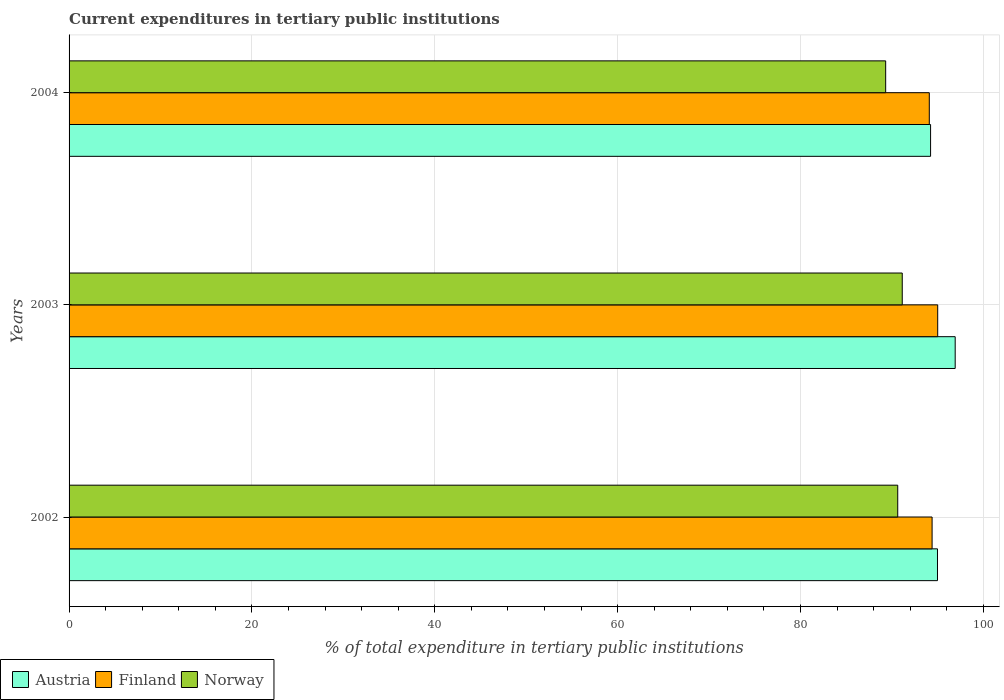How many groups of bars are there?
Provide a short and direct response. 3. Are the number of bars per tick equal to the number of legend labels?
Your answer should be compact. Yes. How many bars are there on the 1st tick from the bottom?
Make the answer very short. 3. What is the label of the 2nd group of bars from the top?
Your response must be concise. 2003. What is the current expenditures in tertiary public institutions in Finland in 2002?
Offer a terse response. 94.4. Across all years, what is the maximum current expenditures in tertiary public institutions in Norway?
Offer a terse response. 91.14. Across all years, what is the minimum current expenditures in tertiary public institutions in Finland?
Provide a succinct answer. 94.09. In which year was the current expenditures in tertiary public institutions in Austria maximum?
Ensure brevity in your answer.  2003. What is the total current expenditures in tertiary public institutions in Austria in the graph?
Provide a short and direct response. 286.15. What is the difference between the current expenditures in tertiary public institutions in Norway in 2003 and that in 2004?
Make the answer very short. 1.81. What is the difference between the current expenditures in tertiary public institutions in Finland in 2003 and the current expenditures in tertiary public institutions in Austria in 2002?
Make the answer very short. 0.02. What is the average current expenditures in tertiary public institutions in Norway per year?
Make the answer very short. 90.37. In the year 2004, what is the difference between the current expenditures in tertiary public institutions in Finland and current expenditures in tertiary public institutions in Norway?
Your answer should be very brief. 4.77. What is the ratio of the current expenditures in tertiary public institutions in Finland in 2002 to that in 2003?
Your answer should be very brief. 0.99. Is the current expenditures in tertiary public institutions in Austria in 2002 less than that in 2003?
Provide a succinct answer. Yes. What is the difference between the highest and the second highest current expenditures in tertiary public institutions in Finland?
Your answer should be compact. 0.61. What is the difference between the highest and the lowest current expenditures in tertiary public institutions in Finland?
Keep it short and to the point. 0.92. Is the sum of the current expenditures in tertiary public institutions in Austria in 2003 and 2004 greater than the maximum current expenditures in tertiary public institutions in Finland across all years?
Offer a terse response. Yes. Is it the case that in every year, the sum of the current expenditures in tertiary public institutions in Norway and current expenditures in tertiary public institutions in Austria is greater than the current expenditures in tertiary public institutions in Finland?
Your response must be concise. Yes. How many bars are there?
Ensure brevity in your answer.  9. Are all the bars in the graph horizontal?
Your answer should be compact. Yes. Does the graph contain any zero values?
Make the answer very short. No. How many legend labels are there?
Give a very brief answer. 3. What is the title of the graph?
Ensure brevity in your answer.  Current expenditures in tertiary public institutions. Does "East Asia (all income levels)" appear as one of the legend labels in the graph?
Offer a very short reply. No. What is the label or title of the X-axis?
Give a very brief answer. % of total expenditure in tertiary public institutions. What is the label or title of the Y-axis?
Your response must be concise. Years. What is the % of total expenditure in tertiary public institutions in Austria in 2002?
Keep it short and to the point. 94.99. What is the % of total expenditure in tertiary public institutions in Finland in 2002?
Offer a terse response. 94.4. What is the % of total expenditure in tertiary public institutions in Norway in 2002?
Provide a succinct answer. 90.64. What is the % of total expenditure in tertiary public institutions of Austria in 2003?
Your response must be concise. 96.93. What is the % of total expenditure in tertiary public institutions in Finland in 2003?
Provide a short and direct response. 95.01. What is the % of total expenditure in tertiary public institutions in Norway in 2003?
Provide a succinct answer. 91.14. What is the % of total expenditure in tertiary public institutions of Austria in 2004?
Your answer should be compact. 94.23. What is the % of total expenditure in tertiary public institutions in Finland in 2004?
Provide a succinct answer. 94.09. What is the % of total expenditure in tertiary public institutions of Norway in 2004?
Provide a succinct answer. 89.32. Across all years, what is the maximum % of total expenditure in tertiary public institutions of Austria?
Keep it short and to the point. 96.93. Across all years, what is the maximum % of total expenditure in tertiary public institutions in Finland?
Ensure brevity in your answer.  95.01. Across all years, what is the maximum % of total expenditure in tertiary public institutions of Norway?
Ensure brevity in your answer.  91.14. Across all years, what is the minimum % of total expenditure in tertiary public institutions of Austria?
Ensure brevity in your answer.  94.23. Across all years, what is the minimum % of total expenditure in tertiary public institutions in Finland?
Your response must be concise. 94.09. Across all years, what is the minimum % of total expenditure in tertiary public institutions of Norway?
Ensure brevity in your answer.  89.32. What is the total % of total expenditure in tertiary public institutions in Austria in the graph?
Your answer should be very brief. 286.15. What is the total % of total expenditure in tertiary public institutions of Finland in the graph?
Your response must be concise. 283.51. What is the total % of total expenditure in tertiary public institutions in Norway in the graph?
Provide a succinct answer. 271.1. What is the difference between the % of total expenditure in tertiary public institutions of Austria in 2002 and that in 2003?
Offer a terse response. -1.94. What is the difference between the % of total expenditure in tertiary public institutions of Finland in 2002 and that in 2003?
Your response must be concise. -0.61. What is the difference between the % of total expenditure in tertiary public institutions of Norway in 2002 and that in 2003?
Provide a succinct answer. -0.49. What is the difference between the % of total expenditure in tertiary public institutions of Austria in 2002 and that in 2004?
Your response must be concise. 0.76. What is the difference between the % of total expenditure in tertiary public institutions in Finland in 2002 and that in 2004?
Offer a terse response. 0.31. What is the difference between the % of total expenditure in tertiary public institutions of Norway in 2002 and that in 2004?
Your answer should be compact. 1.32. What is the difference between the % of total expenditure in tertiary public institutions in Austria in 2003 and that in 2004?
Your response must be concise. 2.69. What is the difference between the % of total expenditure in tertiary public institutions in Finland in 2003 and that in 2004?
Your answer should be compact. 0.92. What is the difference between the % of total expenditure in tertiary public institutions of Norway in 2003 and that in 2004?
Ensure brevity in your answer.  1.81. What is the difference between the % of total expenditure in tertiary public institutions of Austria in 2002 and the % of total expenditure in tertiary public institutions of Finland in 2003?
Provide a succinct answer. -0.02. What is the difference between the % of total expenditure in tertiary public institutions of Austria in 2002 and the % of total expenditure in tertiary public institutions of Norway in 2003?
Provide a short and direct response. 3.85. What is the difference between the % of total expenditure in tertiary public institutions of Finland in 2002 and the % of total expenditure in tertiary public institutions of Norway in 2003?
Your response must be concise. 3.26. What is the difference between the % of total expenditure in tertiary public institutions of Austria in 2002 and the % of total expenditure in tertiary public institutions of Finland in 2004?
Give a very brief answer. 0.9. What is the difference between the % of total expenditure in tertiary public institutions in Austria in 2002 and the % of total expenditure in tertiary public institutions in Norway in 2004?
Provide a succinct answer. 5.67. What is the difference between the % of total expenditure in tertiary public institutions of Finland in 2002 and the % of total expenditure in tertiary public institutions of Norway in 2004?
Your response must be concise. 5.08. What is the difference between the % of total expenditure in tertiary public institutions in Austria in 2003 and the % of total expenditure in tertiary public institutions in Finland in 2004?
Provide a succinct answer. 2.83. What is the difference between the % of total expenditure in tertiary public institutions in Austria in 2003 and the % of total expenditure in tertiary public institutions in Norway in 2004?
Your answer should be compact. 7.6. What is the difference between the % of total expenditure in tertiary public institutions in Finland in 2003 and the % of total expenditure in tertiary public institutions in Norway in 2004?
Give a very brief answer. 5.69. What is the average % of total expenditure in tertiary public institutions in Austria per year?
Your response must be concise. 95.38. What is the average % of total expenditure in tertiary public institutions of Finland per year?
Provide a succinct answer. 94.5. What is the average % of total expenditure in tertiary public institutions of Norway per year?
Your response must be concise. 90.37. In the year 2002, what is the difference between the % of total expenditure in tertiary public institutions of Austria and % of total expenditure in tertiary public institutions of Finland?
Provide a short and direct response. 0.59. In the year 2002, what is the difference between the % of total expenditure in tertiary public institutions of Austria and % of total expenditure in tertiary public institutions of Norway?
Ensure brevity in your answer.  4.35. In the year 2002, what is the difference between the % of total expenditure in tertiary public institutions in Finland and % of total expenditure in tertiary public institutions in Norway?
Your response must be concise. 3.76. In the year 2003, what is the difference between the % of total expenditure in tertiary public institutions in Austria and % of total expenditure in tertiary public institutions in Finland?
Provide a succinct answer. 1.91. In the year 2003, what is the difference between the % of total expenditure in tertiary public institutions of Austria and % of total expenditure in tertiary public institutions of Norway?
Provide a succinct answer. 5.79. In the year 2003, what is the difference between the % of total expenditure in tertiary public institutions in Finland and % of total expenditure in tertiary public institutions in Norway?
Your answer should be compact. 3.88. In the year 2004, what is the difference between the % of total expenditure in tertiary public institutions in Austria and % of total expenditure in tertiary public institutions in Finland?
Give a very brief answer. 0.14. In the year 2004, what is the difference between the % of total expenditure in tertiary public institutions of Austria and % of total expenditure in tertiary public institutions of Norway?
Provide a succinct answer. 4.91. In the year 2004, what is the difference between the % of total expenditure in tertiary public institutions of Finland and % of total expenditure in tertiary public institutions of Norway?
Ensure brevity in your answer.  4.77. What is the ratio of the % of total expenditure in tertiary public institutions of Finland in 2002 to that in 2003?
Keep it short and to the point. 0.99. What is the ratio of the % of total expenditure in tertiary public institutions in Austria in 2002 to that in 2004?
Offer a very short reply. 1.01. What is the ratio of the % of total expenditure in tertiary public institutions of Norway in 2002 to that in 2004?
Provide a short and direct response. 1.01. What is the ratio of the % of total expenditure in tertiary public institutions in Austria in 2003 to that in 2004?
Offer a terse response. 1.03. What is the ratio of the % of total expenditure in tertiary public institutions in Finland in 2003 to that in 2004?
Your response must be concise. 1.01. What is the ratio of the % of total expenditure in tertiary public institutions in Norway in 2003 to that in 2004?
Keep it short and to the point. 1.02. What is the difference between the highest and the second highest % of total expenditure in tertiary public institutions in Austria?
Ensure brevity in your answer.  1.94. What is the difference between the highest and the second highest % of total expenditure in tertiary public institutions in Finland?
Keep it short and to the point. 0.61. What is the difference between the highest and the second highest % of total expenditure in tertiary public institutions of Norway?
Ensure brevity in your answer.  0.49. What is the difference between the highest and the lowest % of total expenditure in tertiary public institutions of Austria?
Give a very brief answer. 2.69. What is the difference between the highest and the lowest % of total expenditure in tertiary public institutions of Finland?
Your response must be concise. 0.92. What is the difference between the highest and the lowest % of total expenditure in tertiary public institutions of Norway?
Your answer should be very brief. 1.81. 